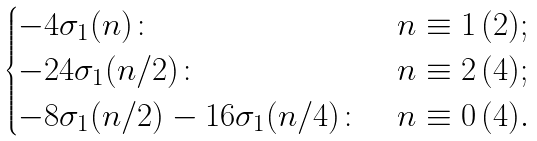<formula> <loc_0><loc_0><loc_500><loc_500>\begin{cases} - 4 \sigma _ { 1 } ( n ) \colon & n \equiv 1 \, ( 2 ) ; \\ - 2 4 \sigma _ { 1 } ( n / 2 ) \colon & n \equiv 2 \, ( 4 ) ; \\ - 8 \sigma _ { 1 } ( n / 2 ) - 1 6 \sigma _ { 1 } ( n / 4 ) \colon & n \equiv 0 \, ( 4 ) . \end{cases}</formula> 